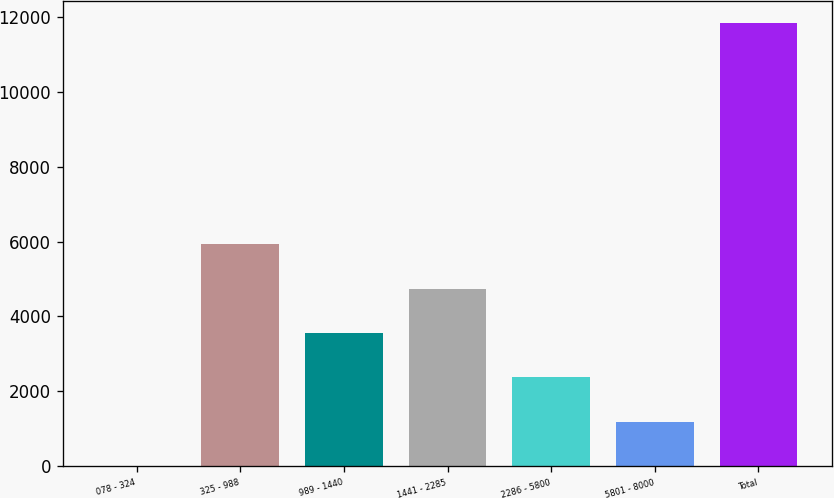Convert chart. <chart><loc_0><loc_0><loc_500><loc_500><bar_chart><fcel>078 - 324<fcel>325 - 988<fcel>989 - 1440<fcel>1441 - 2285<fcel>2286 - 5800<fcel>5801 - 8000<fcel>Total<nl><fcel>4<fcel>5924.5<fcel>3556.3<fcel>4740.4<fcel>2372.2<fcel>1188.1<fcel>11845<nl></chart> 